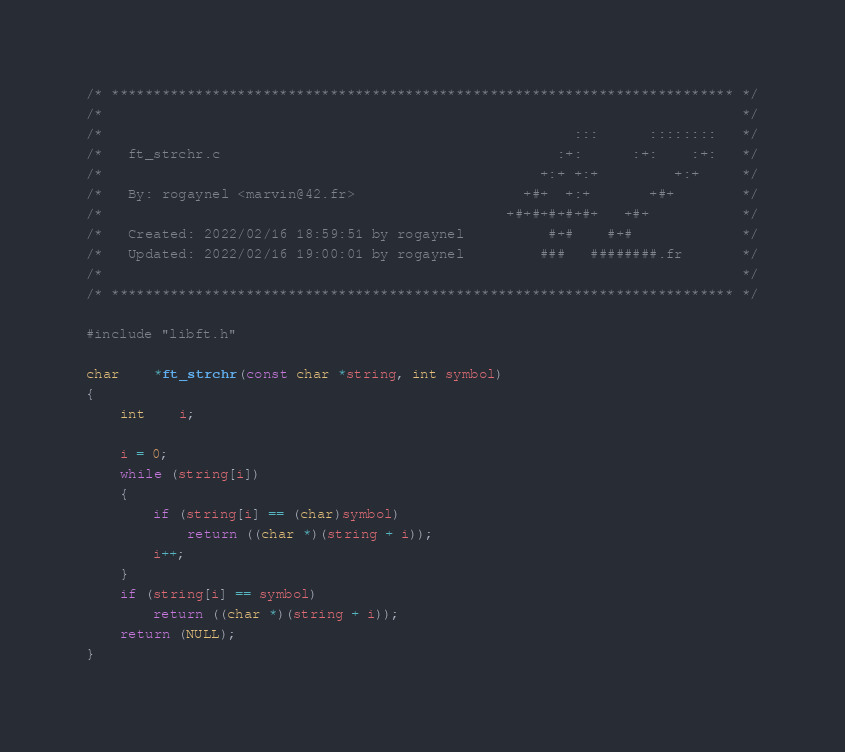Convert code to text. <code><loc_0><loc_0><loc_500><loc_500><_C_>/* ************************************************************************** */
/*                                                                            */
/*                                                        :::      ::::::::   */
/*   ft_strchr.c                                        :+:      :+:    :+:   */
/*                                                    +:+ +:+         +:+     */
/*   By: rogaynel <marvin@42.fr>                    +#+  +:+       +#+        */
/*                                                +#+#+#+#+#+   +#+           */
/*   Created: 2022/02/16 18:59:51 by rogaynel          #+#    #+#             */
/*   Updated: 2022/02/16 19:00:01 by rogaynel         ###   ########.fr       */
/*                                                                            */
/* ************************************************************************** */

#include "libft.h"

char	*ft_strchr(const char *string, int symbol)
{
	int	i;

	i = 0;
	while (string[i])
	{
		if (string[i] == (char)symbol)
			return ((char *)(string + i));
		i++;
	}
	if (string[i] == symbol)
		return ((char *)(string + i));
	return (NULL);
}
</code> 